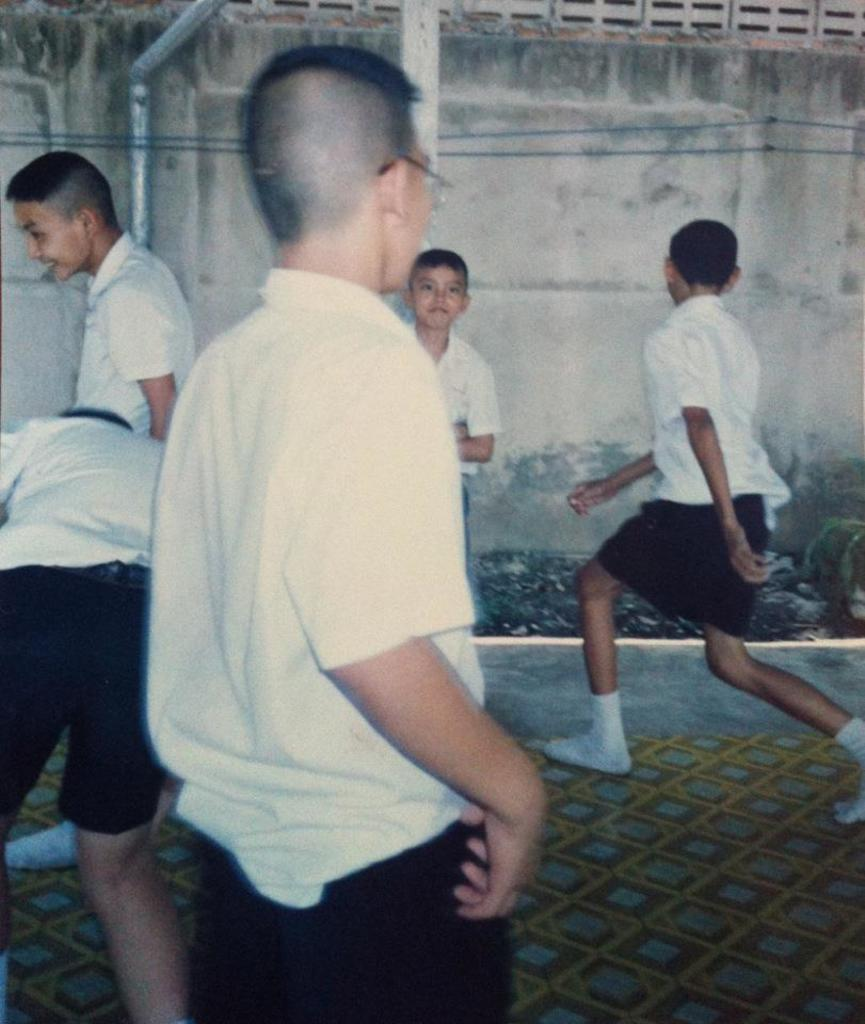Who is present in the image? There are children in the image. What are the children wearing? The children are wearing white shirts. Where are the children located in the image? The children are on the ground. What can be seen in the background of the image? There is a wall in the background of the image. How much mist can be seen in the image? There is no mist present in the image. What type of toad is sitting next to the children in the image? There is no toad present in the image. 